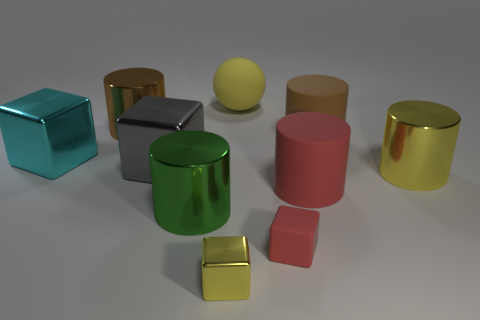What shape is the big metal thing that is the same color as the small metallic cube?
Make the answer very short. Cylinder. There is a large gray metal thing; does it have the same shape as the tiny thing that is in front of the small red object?
Provide a succinct answer. Yes. Does the metallic object in front of the green cylinder have the same size as the big ball?
Your response must be concise. No. What is the shape of the brown matte thing that is the same size as the brown metal thing?
Your answer should be very brief. Cylinder. Does the gray thing have the same shape as the small yellow metallic thing?
Ensure brevity in your answer.  Yes. How many large metallic things have the same shape as the tiny metallic thing?
Make the answer very short. 2. There is a big cyan metallic cube; what number of big cyan cubes are on the right side of it?
Offer a very short reply. 0. There is a metallic cylinder behind the big gray metallic thing; does it have the same color as the big ball?
Ensure brevity in your answer.  No. How many brown metal cylinders are the same size as the cyan metallic thing?
Your answer should be very brief. 1. The large yellow thing that is the same material as the tiny yellow thing is what shape?
Provide a succinct answer. Cylinder. 